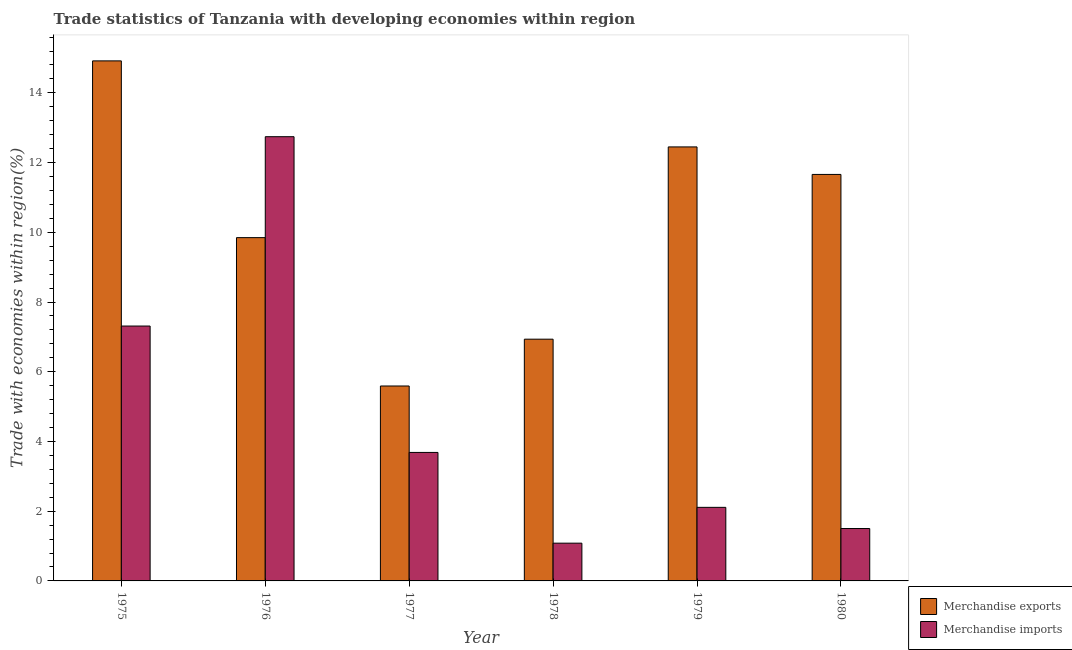How many different coloured bars are there?
Your response must be concise. 2. Are the number of bars on each tick of the X-axis equal?
Offer a terse response. Yes. How many bars are there on the 1st tick from the right?
Offer a terse response. 2. What is the label of the 5th group of bars from the left?
Your answer should be compact. 1979. What is the merchandise exports in 1980?
Provide a succinct answer. 11.66. Across all years, what is the maximum merchandise exports?
Offer a terse response. 14.92. Across all years, what is the minimum merchandise imports?
Ensure brevity in your answer.  1.08. In which year was the merchandise exports maximum?
Offer a terse response. 1975. In which year was the merchandise imports minimum?
Keep it short and to the point. 1978. What is the total merchandise imports in the graph?
Your response must be concise. 28.44. What is the difference between the merchandise exports in 1975 and that in 1980?
Provide a short and direct response. 3.26. What is the difference between the merchandise exports in 1975 and the merchandise imports in 1979?
Your answer should be very brief. 2.47. What is the average merchandise exports per year?
Give a very brief answer. 10.23. What is the ratio of the merchandise imports in 1975 to that in 1977?
Provide a succinct answer. 1.98. Is the merchandise exports in 1976 less than that in 1980?
Your answer should be very brief. Yes. Is the difference between the merchandise imports in 1975 and 1977 greater than the difference between the merchandise exports in 1975 and 1977?
Ensure brevity in your answer.  No. What is the difference between the highest and the second highest merchandise imports?
Ensure brevity in your answer.  5.43. What is the difference between the highest and the lowest merchandise exports?
Keep it short and to the point. 9.33. What does the 1st bar from the left in 1980 represents?
Your response must be concise. Merchandise exports. Are all the bars in the graph horizontal?
Give a very brief answer. No. Does the graph contain any zero values?
Your response must be concise. No. How are the legend labels stacked?
Provide a short and direct response. Vertical. What is the title of the graph?
Your answer should be compact. Trade statistics of Tanzania with developing economies within region. What is the label or title of the Y-axis?
Your answer should be compact. Trade with economies within region(%). What is the Trade with economies within region(%) of Merchandise exports in 1975?
Keep it short and to the point. 14.92. What is the Trade with economies within region(%) of Merchandise imports in 1975?
Provide a short and direct response. 7.31. What is the Trade with economies within region(%) of Merchandise exports in 1976?
Keep it short and to the point. 9.85. What is the Trade with economies within region(%) of Merchandise imports in 1976?
Ensure brevity in your answer.  12.74. What is the Trade with economies within region(%) in Merchandise exports in 1977?
Make the answer very short. 5.59. What is the Trade with economies within region(%) of Merchandise imports in 1977?
Give a very brief answer. 3.69. What is the Trade with economies within region(%) of Merchandise exports in 1978?
Offer a very short reply. 6.93. What is the Trade with economies within region(%) in Merchandise imports in 1978?
Provide a short and direct response. 1.08. What is the Trade with economies within region(%) in Merchandise exports in 1979?
Make the answer very short. 12.45. What is the Trade with economies within region(%) of Merchandise imports in 1979?
Your answer should be very brief. 2.11. What is the Trade with economies within region(%) in Merchandise exports in 1980?
Give a very brief answer. 11.66. What is the Trade with economies within region(%) in Merchandise imports in 1980?
Give a very brief answer. 1.5. Across all years, what is the maximum Trade with economies within region(%) in Merchandise exports?
Provide a succinct answer. 14.92. Across all years, what is the maximum Trade with economies within region(%) of Merchandise imports?
Give a very brief answer. 12.74. Across all years, what is the minimum Trade with economies within region(%) of Merchandise exports?
Your response must be concise. 5.59. Across all years, what is the minimum Trade with economies within region(%) of Merchandise imports?
Keep it short and to the point. 1.08. What is the total Trade with economies within region(%) of Merchandise exports in the graph?
Your answer should be very brief. 61.4. What is the total Trade with economies within region(%) in Merchandise imports in the graph?
Provide a short and direct response. 28.44. What is the difference between the Trade with economies within region(%) of Merchandise exports in 1975 and that in 1976?
Your answer should be compact. 5.07. What is the difference between the Trade with economies within region(%) in Merchandise imports in 1975 and that in 1976?
Your answer should be very brief. -5.43. What is the difference between the Trade with economies within region(%) in Merchandise exports in 1975 and that in 1977?
Ensure brevity in your answer.  9.33. What is the difference between the Trade with economies within region(%) of Merchandise imports in 1975 and that in 1977?
Your answer should be very brief. 3.63. What is the difference between the Trade with economies within region(%) of Merchandise exports in 1975 and that in 1978?
Keep it short and to the point. 7.98. What is the difference between the Trade with economies within region(%) of Merchandise imports in 1975 and that in 1978?
Offer a very short reply. 6.23. What is the difference between the Trade with economies within region(%) in Merchandise exports in 1975 and that in 1979?
Ensure brevity in your answer.  2.47. What is the difference between the Trade with economies within region(%) of Merchandise imports in 1975 and that in 1979?
Your response must be concise. 5.2. What is the difference between the Trade with economies within region(%) of Merchandise exports in 1975 and that in 1980?
Your answer should be compact. 3.26. What is the difference between the Trade with economies within region(%) of Merchandise imports in 1975 and that in 1980?
Give a very brief answer. 5.81. What is the difference between the Trade with economies within region(%) of Merchandise exports in 1976 and that in 1977?
Provide a succinct answer. 4.26. What is the difference between the Trade with economies within region(%) of Merchandise imports in 1976 and that in 1977?
Keep it short and to the point. 9.06. What is the difference between the Trade with economies within region(%) of Merchandise exports in 1976 and that in 1978?
Provide a succinct answer. 2.91. What is the difference between the Trade with economies within region(%) of Merchandise imports in 1976 and that in 1978?
Keep it short and to the point. 11.66. What is the difference between the Trade with economies within region(%) in Merchandise exports in 1976 and that in 1979?
Make the answer very short. -2.6. What is the difference between the Trade with economies within region(%) of Merchandise imports in 1976 and that in 1979?
Your response must be concise. 10.63. What is the difference between the Trade with economies within region(%) in Merchandise exports in 1976 and that in 1980?
Provide a succinct answer. -1.81. What is the difference between the Trade with economies within region(%) of Merchandise imports in 1976 and that in 1980?
Your answer should be very brief. 11.24. What is the difference between the Trade with economies within region(%) in Merchandise exports in 1977 and that in 1978?
Your response must be concise. -1.34. What is the difference between the Trade with economies within region(%) of Merchandise imports in 1977 and that in 1978?
Keep it short and to the point. 2.6. What is the difference between the Trade with economies within region(%) of Merchandise exports in 1977 and that in 1979?
Your response must be concise. -6.86. What is the difference between the Trade with economies within region(%) in Merchandise imports in 1977 and that in 1979?
Your response must be concise. 1.58. What is the difference between the Trade with economies within region(%) of Merchandise exports in 1977 and that in 1980?
Offer a terse response. -6.07. What is the difference between the Trade with economies within region(%) of Merchandise imports in 1977 and that in 1980?
Your response must be concise. 2.18. What is the difference between the Trade with economies within region(%) of Merchandise exports in 1978 and that in 1979?
Provide a succinct answer. -5.52. What is the difference between the Trade with economies within region(%) of Merchandise imports in 1978 and that in 1979?
Ensure brevity in your answer.  -1.03. What is the difference between the Trade with economies within region(%) of Merchandise exports in 1978 and that in 1980?
Your answer should be compact. -4.73. What is the difference between the Trade with economies within region(%) in Merchandise imports in 1978 and that in 1980?
Your answer should be compact. -0.42. What is the difference between the Trade with economies within region(%) of Merchandise exports in 1979 and that in 1980?
Your answer should be very brief. 0.79. What is the difference between the Trade with economies within region(%) in Merchandise imports in 1979 and that in 1980?
Make the answer very short. 0.61. What is the difference between the Trade with economies within region(%) in Merchandise exports in 1975 and the Trade with economies within region(%) in Merchandise imports in 1976?
Your answer should be compact. 2.17. What is the difference between the Trade with economies within region(%) in Merchandise exports in 1975 and the Trade with economies within region(%) in Merchandise imports in 1977?
Ensure brevity in your answer.  11.23. What is the difference between the Trade with economies within region(%) in Merchandise exports in 1975 and the Trade with economies within region(%) in Merchandise imports in 1978?
Keep it short and to the point. 13.83. What is the difference between the Trade with economies within region(%) of Merchandise exports in 1975 and the Trade with economies within region(%) of Merchandise imports in 1979?
Provide a short and direct response. 12.81. What is the difference between the Trade with economies within region(%) of Merchandise exports in 1975 and the Trade with economies within region(%) of Merchandise imports in 1980?
Give a very brief answer. 13.41. What is the difference between the Trade with economies within region(%) of Merchandise exports in 1976 and the Trade with economies within region(%) of Merchandise imports in 1977?
Your response must be concise. 6.16. What is the difference between the Trade with economies within region(%) in Merchandise exports in 1976 and the Trade with economies within region(%) in Merchandise imports in 1978?
Offer a terse response. 8.76. What is the difference between the Trade with economies within region(%) of Merchandise exports in 1976 and the Trade with economies within region(%) of Merchandise imports in 1979?
Provide a short and direct response. 7.74. What is the difference between the Trade with economies within region(%) in Merchandise exports in 1976 and the Trade with economies within region(%) in Merchandise imports in 1980?
Offer a terse response. 8.34. What is the difference between the Trade with economies within region(%) in Merchandise exports in 1977 and the Trade with economies within region(%) in Merchandise imports in 1978?
Your answer should be very brief. 4.51. What is the difference between the Trade with economies within region(%) of Merchandise exports in 1977 and the Trade with economies within region(%) of Merchandise imports in 1979?
Give a very brief answer. 3.48. What is the difference between the Trade with economies within region(%) in Merchandise exports in 1977 and the Trade with economies within region(%) in Merchandise imports in 1980?
Your answer should be compact. 4.09. What is the difference between the Trade with economies within region(%) in Merchandise exports in 1978 and the Trade with economies within region(%) in Merchandise imports in 1979?
Your answer should be very brief. 4.82. What is the difference between the Trade with economies within region(%) in Merchandise exports in 1978 and the Trade with economies within region(%) in Merchandise imports in 1980?
Offer a very short reply. 5.43. What is the difference between the Trade with economies within region(%) of Merchandise exports in 1979 and the Trade with economies within region(%) of Merchandise imports in 1980?
Offer a very short reply. 10.95. What is the average Trade with economies within region(%) in Merchandise exports per year?
Offer a very short reply. 10.23. What is the average Trade with economies within region(%) in Merchandise imports per year?
Keep it short and to the point. 4.74. In the year 1975, what is the difference between the Trade with economies within region(%) in Merchandise exports and Trade with economies within region(%) in Merchandise imports?
Give a very brief answer. 7.61. In the year 1976, what is the difference between the Trade with economies within region(%) in Merchandise exports and Trade with economies within region(%) in Merchandise imports?
Your answer should be very brief. -2.9. In the year 1977, what is the difference between the Trade with economies within region(%) of Merchandise exports and Trade with economies within region(%) of Merchandise imports?
Offer a very short reply. 1.91. In the year 1978, what is the difference between the Trade with economies within region(%) in Merchandise exports and Trade with economies within region(%) in Merchandise imports?
Provide a short and direct response. 5.85. In the year 1979, what is the difference between the Trade with economies within region(%) in Merchandise exports and Trade with economies within region(%) in Merchandise imports?
Your answer should be very brief. 10.34. In the year 1980, what is the difference between the Trade with economies within region(%) in Merchandise exports and Trade with economies within region(%) in Merchandise imports?
Provide a succinct answer. 10.16. What is the ratio of the Trade with economies within region(%) of Merchandise exports in 1975 to that in 1976?
Your answer should be very brief. 1.51. What is the ratio of the Trade with economies within region(%) of Merchandise imports in 1975 to that in 1976?
Ensure brevity in your answer.  0.57. What is the ratio of the Trade with economies within region(%) in Merchandise exports in 1975 to that in 1977?
Your answer should be compact. 2.67. What is the ratio of the Trade with economies within region(%) of Merchandise imports in 1975 to that in 1977?
Your answer should be compact. 1.98. What is the ratio of the Trade with economies within region(%) in Merchandise exports in 1975 to that in 1978?
Ensure brevity in your answer.  2.15. What is the ratio of the Trade with economies within region(%) of Merchandise imports in 1975 to that in 1978?
Offer a very short reply. 6.75. What is the ratio of the Trade with economies within region(%) of Merchandise exports in 1975 to that in 1979?
Ensure brevity in your answer.  1.2. What is the ratio of the Trade with economies within region(%) in Merchandise imports in 1975 to that in 1979?
Provide a succinct answer. 3.46. What is the ratio of the Trade with economies within region(%) in Merchandise exports in 1975 to that in 1980?
Keep it short and to the point. 1.28. What is the ratio of the Trade with economies within region(%) in Merchandise imports in 1975 to that in 1980?
Provide a succinct answer. 4.86. What is the ratio of the Trade with economies within region(%) of Merchandise exports in 1976 to that in 1977?
Give a very brief answer. 1.76. What is the ratio of the Trade with economies within region(%) in Merchandise imports in 1976 to that in 1977?
Your response must be concise. 3.46. What is the ratio of the Trade with economies within region(%) of Merchandise exports in 1976 to that in 1978?
Provide a succinct answer. 1.42. What is the ratio of the Trade with economies within region(%) in Merchandise imports in 1976 to that in 1978?
Your response must be concise. 11.77. What is the ratio of the Trade with economies within region(%) of Merchandise exports in 1976 to that in 1979?
Keep it short and to the point. 0.79. What is the ratio of the Trade with economies within region(%) in Merchandise imports in 1976 to that in 1979?
Provide a succinct answer. 6.04. What is the ratio of the Trade with economies within region(%) in Merchandise exports in 1976 to that in 1980?
Make the answer very short. 0.84. What is the ratio of the Trade with economies within region(%) in Merchandise imports in 1976 to that in 1980?
Your response must be concise. 8.48. What is the ratio of the Trade with economies within region(%) in Merchandise exports in 1977 to that in 1978?
Give a very brief answer. 0.81. What is the ratio of the Trade with economies within region(%) in Merchandise imports in 1977 to that in 1978?
Ensure brevity in your answer.  3.4. What is the ratio of the Trade with economies within region(%) in Merchandise exports in 1977 to that in 1979?
Make the answer very short. 0.45. What is the ratio of the Trade with economies within region(%) of Merchandise imports in 1977 to that in 1979?
Make the answer very short. 1.75. What is the ratio of the Trade with economies within region(%) in Merchandise exports in 1977 to that in 1980?
Keep it short and to the point. 0.48. What is the ratio of the Trade with economies within region(%) of Merchandise imports in 1977 to that in 1980?
Give a very brief answer. 2.45. What is the ratio of the Trade with economies within region(%) in Merchandise exports in 1978 to that in 1979?
Your response must be concise. 0.56. What is the ratio of the Trade with economies within region(%) of Merchandise imports in 1978 to that in 1979?
Keep it short and to the point. 0.51. What is the ratio of the Trade with economies within region(%) of Merchandise exports in 1978 to that in 1980?
Offer a terse response. 0.59. What is the ratio of the Trade with economies within region(%) of Merchandise imports in 1978 to that in 1980?
Provide a succinct answer. 0.72. What is the ratio of the Trade with economies within region(%) in Merchandise exports in 1979 to that in 1980?
Offer a very short reply. 1.07. What is the ratio of the Trade with economies within region(%) of Merchandise imports in 1979 to that in 1980?
Your answer should be compact. 1.4. What is the difference between the highest and the second highest Trade with economies within region(%) of Merchandise exports?
Your answer should be very brief. 2.47. What is the difference between the highest and the second highest Trade with economies within region(%) in Merchandise imports?
Make the answer very short. 5.43. What is the difference between the highest and the lowest Trade with economies within region(%) of Merchandise exports?
Provide a short and direct response. 9.33. What is the difference between the highest and the lowest Trade with economies within region(%) in Merchandise imports?
Offer a very short reply. 11.66. 